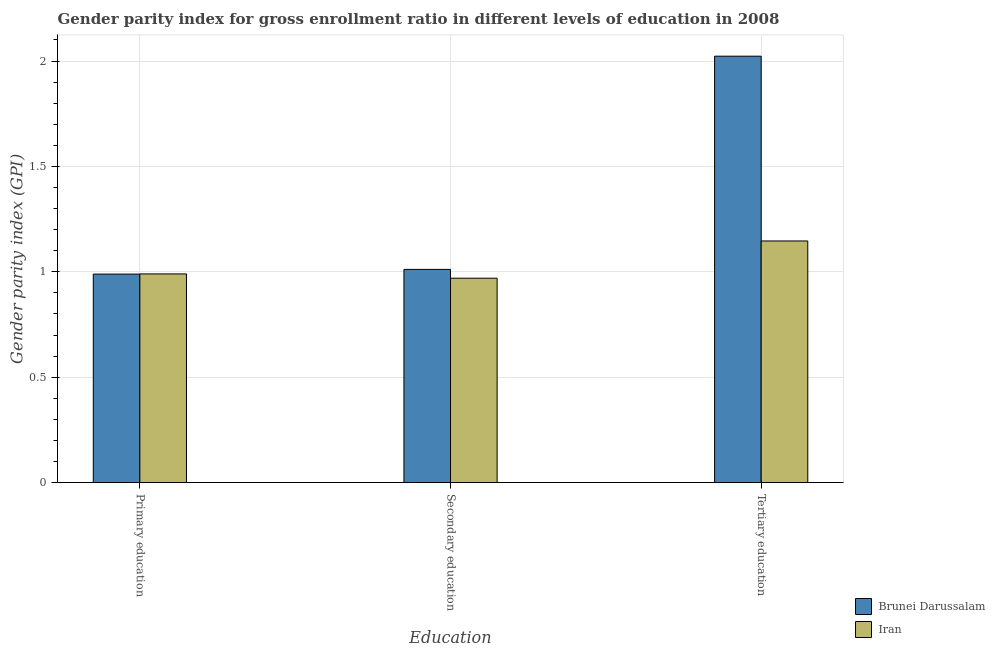How many different coloured bars are there?
Offer a very short reply. 2. How many groups of bars are there?
Make the answer very short. 3. Are the number of bars on each tick of the X-axis equal?
Your answer should be compact. Yes. How many bars are there on the 1st tick from the left?
Keep it short and to the point. 2. What is the label of the 1st group of bars from the left?
Give a very brief answer. Primary education. What is the gender parity index in secondary education in Iran?
Your answer should be very brief. 0.97. Across all countries, what is the maximum gender parity index in tertiary education?
Make the answer very short. 2.02. Across all countries, what is the minimum gender parity index in tertiary education?
Your response must be concise. 1.15. In which country was the gender parity index in tertiary education maximum?
Provide a short and direct response. Brunei Darussalam. In which country was the gender parity index in secondary education minimum?
Offer a very short reply. Iran. What is the total gender parity index in tertiary education in the graph?
Provide a short and direct response. 3.17. What is the difference between the gender parity index in primary education in Iran and that in Brunei Darussalam?
Give a very brief answer. 0. What is the difference between the gender parity index in secondary education in Iran and the gender parity index in tertiary education in Brunei Darussalam?
Offer a very short reply. -1.05. What is the average gender parity index in tertiary education per country?
Offer a terse response. 1.58. What is the difference between the gender parity index in primary education and gender parity index in secondary education in Brunei Darussalam?
Offer a very short reply. -0.02. What is the ratio of the gender parity index in primary education in Brunei Darussalam to that in Iran?
Keep it short and to the point. 1. Is the difference between the gender parity index in tertiary education in Brunei Darussalam and Iran greater than the difference between the gender parity index in primary education in Brunei Darussalam and Iran?
Provide a short and direct response. Yes. What is the difference between the highest and the second highest gender parity index in primary education?
Offer a very short reply. 0. What is the difference between the highest and the lowest gender parity index in secondary education?
Offer a very short reply. 0.04. What does the 1st bar from the left in Primary education represents?
Provide a succinct answer. Brunei Darussalam. What does the 2nd bar from the right in Primary education represents?
Give a very brief answer. Brunei Darussalam. Is it the case that in every country, the sum of the gender parity index in primary education and gender parity index in secondary education is greater than the gender parity index in tertiary education?
Offer a terse response. No. Are all the bars in the graph horizontal?
Your answer should be very brief. No. Does the graph contain grids?
Provide a succinct answer. Yes. How many legend labels are there?
Keep it short and to the point. 2. What is the title of the graph?
Provide a succinct answer. Gender parity index for gross enrollment ratio in different levels of education in 2008. What is the label or title of the X-axis?
Offer a terse response. Education. What is the label or title of the Y-axis?
Keep it short and to the point. Gender parity index (GPI). What is the Gender parity index (GPI) of Brunei Darussalam in Primary education?
Ensure brevity in your answer.  0.99. What is the Gender parity index (GPI) of Iran in Primary education?
Offer a very short reply. 0.99. What is the Gender parity index (GPI) in Brunei Darussalam in Secondary education?
Offer a very short reply. 1.01. What is the Gender parity index (GPI) in Iran in Secondary education?
Provide a succinct answer. 0.97. What is the Gender parity index (GPI) of Brunei Darussalam in Tertiary education?
Provide a short and direct response. 2.02. What is the Gender parity index (GPI) of Iran in Tertiary education?
Provide a succinct answer. 1.15. Across all Education, what is the maximum Gender parity index (GPI) in Brunei Darussalam?
Your answer should be compact. 2.02. Across all Education, what is the maximum Gender parity index (GPI) of Iran?
Make the answer very short. 1.15. Across all Education, what is the minimum Gender parity index (GPI) in Brunei Darussalam?
Your response must be concise. 0.99. Across all Education, what is the minimum Gender parity index (GPI) of Iran?
Keep it short and to the point. 0.97. What is the total Gender parity index (GPI) in Brunei Darussalam in the graph?
Your answer should be very brief. 4.02. What is the total Gender parity index (GPI) in Iran in the graph?
Your answer should be very brief. 3.11. What is the difference between the Gender parity index (GPI) of Brunei Darussalam in Primary education and that in Secondary education?
Offer a very short reply. -0.02. What is the difference between the Gender parity index (GPI) in Iran in Primary education and that in Secondary education?
Your answer should be compact. 0.02. What is the difference between the Gender parity index (GPI) of Brunei Darussalam in Primary education and that in Tertiary education?
Provide a succinct answer. -1.03. What is the difference between the Gender parity index (GPI) in Iran in Primary education and that in Tertiary education?
Your answer should be compact. -0.16. What is the difference between the Gender parity index (GPI) in Brunei Darussalam in Secondary education and that in Tertiary education?
Offer a very short reply. -1.01. What is the difference between the Gender parity index (GPI) in Iran in Secondary education and that in Tertiary education?
Provide a succinct answer. -0.18. What is the difference between the Gender parity index (GPI) of Brunei Darussalam in Primary education and the Gender parity index (GPI) of Iran in Secondary education?
Offer a very short reply. 0.02. What is the difference between the Gender parity index (GPI) of Brunei Darussalam in Primary education and the Gender parity index (GPI) of Iran in Tertiary education?
Offer a terse response. -0.16. What is the difference between the Gender parity index (GPI) of Brunei Darussalam in Secondary education and the Gender parity index (GPI) of Iran in Tertiary education?
Give a very brief answer. -0.13. What is the average Gender parity index (GPI) in Brunei Darussalam per Education?
Keep it short and to the point. 1.34. What is the average Gender parity index (GPI) in Iran per Education?
Your response must be concise. 1.04. What is the difference between the Gender parity index (GPI) of Brunei Darussalam and Gender parity index (GPI) of Iran in Primary education?
Make the answer very short. -0. What is the difference between the Gender parity index (GPI) of Brunei Darussalam and Gender parity index (GPI) of Iran in Secondary education?
Offer a terse response. 0.04. What is the difference between the Gender parity index (GPI) of Brunei Darussalam and Gender parity index (GPI) of Iran in Tertiary education?
Provide a short and direct response. 0.88. What is the ratio of the Gender parity index (GPI) in Iran in Primary education to that in Secondary education?
Give a very brief answer. 1.02. What is the ratio of the Gender parity index (GPI) of Brunei Darussalam in Primary education to that in Tertiary education?
Offer a very short reply. 0.49. What is the ratio of the Gender parity index (GPI) in Iran in Primary education to that in Tertiary education?
Keep it short and to the point. 0.86. What is the ratio of the Gender parity index (GPI) of Iran in Secondary education to that in Tertiary education?
Provide a succinct answer. 0.85. What is the difference between the highest and the second highest Gender parity index (GPI) of Brunei Darussalam?
Offer a very short reply. 1.01. What is the difference between the highest and the second highest Gender parity index (GPI) in Iran?
Offer a terse response. 0.16. What is the difference between the highest and the lowest Gender parity index (GPI) in Brunei Darussalam?
Keep it short and to the point. 1.03. What is the difference between the highest and the lowest Gender parity index (GPI) of Iran?
Your answer should be very brief. 0.18. 